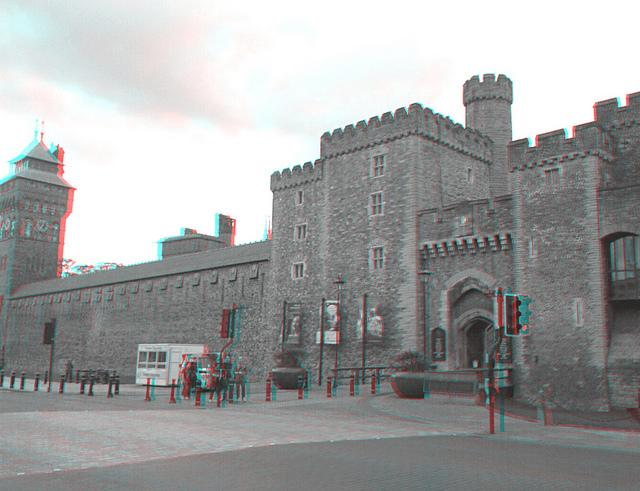What sort of building stand in could this building substitute for in a movie? castle 